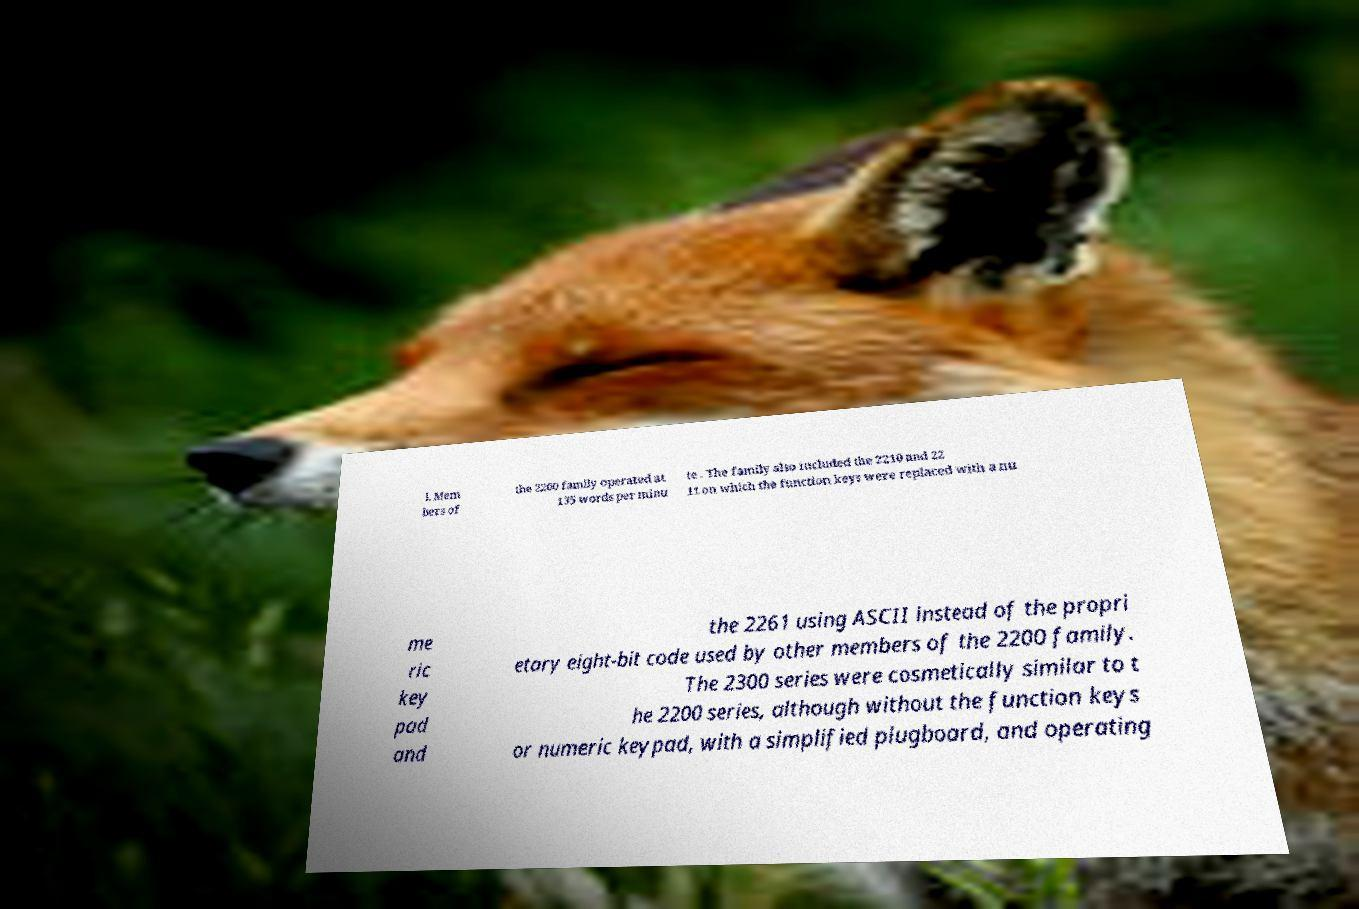For documentation purposes, I need the text within this image transcribed. Could you provide that? l. Mem bers of the 2200 family operated at 135 words per minu te . The family also included the 2210 and 22 11 on which the function keys were replaced with a nu me ric key pad and the 2261 using ASCII instead of the propri etary eight-bit code used by other members of the 2200 family. The 2300 series were cosmetically similar to t he 2200 series, although without the function keys or numeric keypad, with a simplified plugboard, and operating 